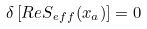<formula> <loc_0><loc_0><loc_500><loc_500>\delta \left [ R e S _ { \mathit e f f } ( x _ { a } ) \right ] = 0</formula> 